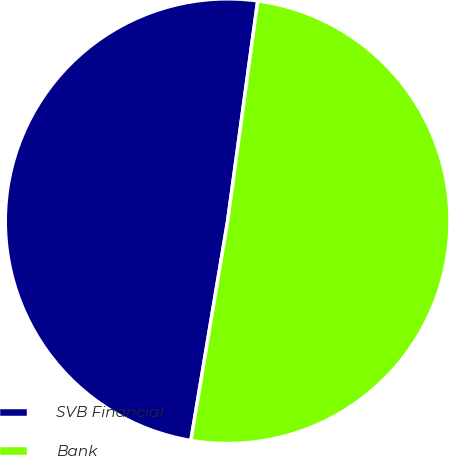Convert chart. <chart><loc_0><loc_0><loc_500><loc_500><pie_chart><fcel>SVB Financial<fcel>Bank<nl><fcel>49.52%<fcel>50.48%<nl></chart> 